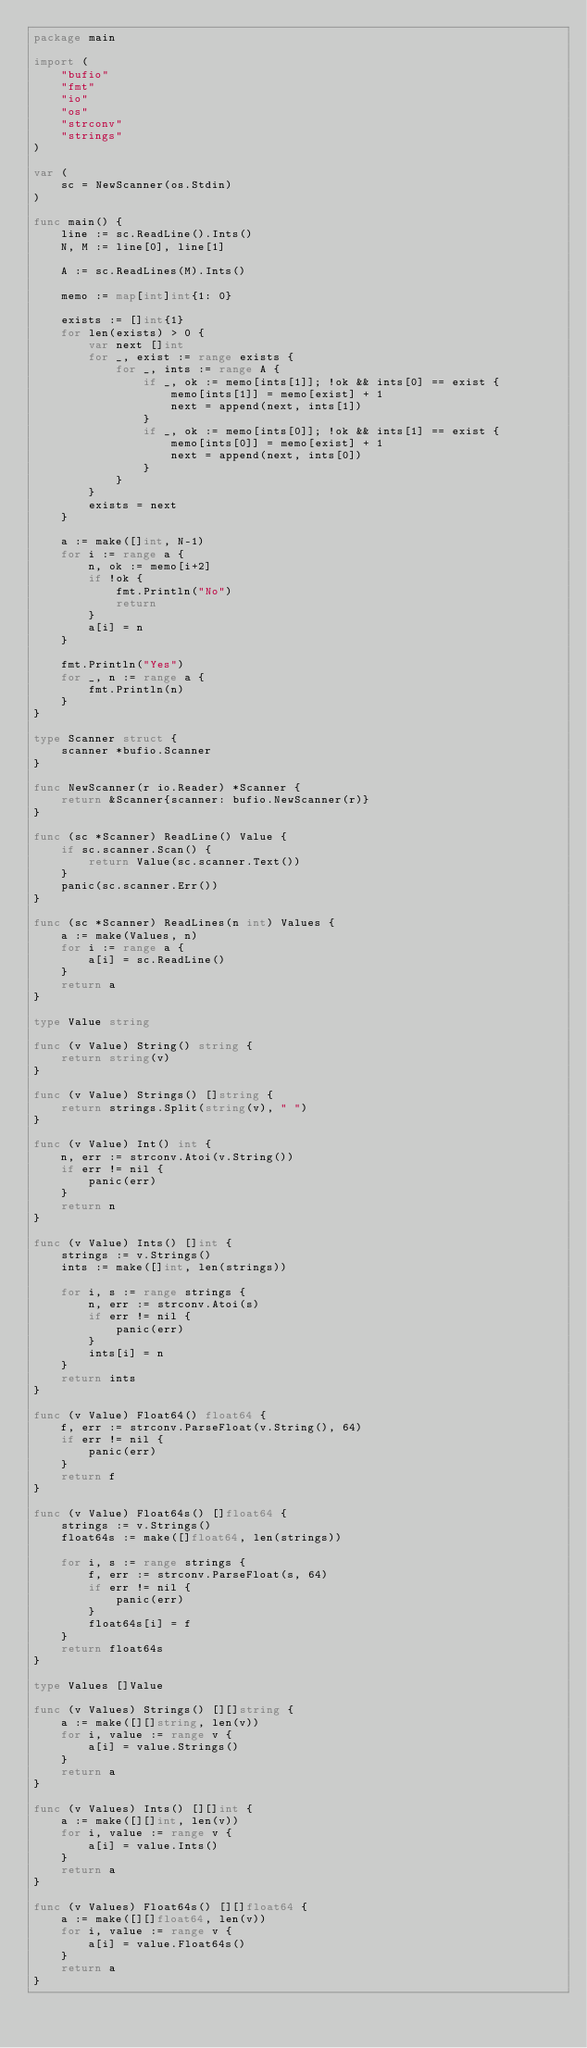Convert code to text. <code><loc_0><loc_0><loc_500><loc_500><_Go_>package main

import (
	"bufio"
	"fmt"
	"io"
	"os"
	"strconv"
	"strings"
)

var (
	sc = NewScanner(os.Stdin)
)

func main() {
	line := sc.ReadLine().Ints()
	N, M := line[0], line[1]

	A := sc.ReadLines(M).Ints()

	memo := map[int]int{1: 0}

	exists := []int{1}
	for len(exists) > 0 {
		var next []int
		for _, exist := range exists {
			for _, ints := range A {
				if _, ok := memo[ints[1]]; !ok && ints[0] == exist {
					memo[ints[1]] = memo[exist] + 1
					next = append(next, ints[1])
				}
				if _, ok := memo[ints[0]]; !ok && ints[1] == exist {
					memo[ints[0]] = memo[exist] + 1
					next = append(next, ints[0])
				}
			}
		}
		exists = next
	}

	a := make([]int, N-1)
	for i := range a {
		n, ok := memo[i+2]
		if !ok {
			fmt.Println("No")
			return
		}
		a[i] = n
	}

	fmt.Println("Yes")
	for _, n := range a {
		fmt.Println(n)
	}
}

type Scanner struct {
	scanner *bufio.Scanner
}

func NewScanner(r io.Reader) *Scanner {
	return &Scanner{scanner: bufio.NewScanner(r)}
}

func (sc *Scanner) ReadLine() Value {
	if sc.scanner.Scan() {
		return Value(sc.scanner.Text())
	}
	panic(sc.scanner.Err())
}

func (sc *Scanner) ReadLines(n int) Values {
	a := make(Values, n)
	for i := range a {
		a[i] = sc.ReadLine()
	}
	return a
}

type Value string

func (v Value) String() string {
	return string(v)
}

func (v Value) Strings() []string {
	return strings.Split(string(v), " ")
}

func (v Value) Int() int {
	n, err := strconv.Atoi(v.String())
	if err != nil {
		panic(err)
	}
	return n
}

func (v Value) Ints() []int {
	strings := v.Strings()
	ints := make([]int, len(strings))

	for i, s := range strings {
		n, err := strconv.Atoi(s)
		if err != nil {
			panic(err)
		}
		ints[i] = n
	}
	return ints
}

func (v Value) Float64() float64 {
	f, err := strconv.ParseFloat(v.String(), 64)
	if err != nil {
		panic(err)
	}
	return f
}

func (v Value) Float64s() []float64 {
	strings := v.Strings()
	float64s := make([]float64, len(strings))

	for i, s := range strings {
		f, err := strconv.ParseFloat(s, 64)
		if err != nil {
			panic(err)
		}
		float64s[i] = f
	}
	return float64s
}

type Values []Value

func (v Values) Strings() [][]string {
	a := make([][]string, len(v))
	for i, value := range v {
		a[i] = value.Strings()
	}
	return a
}

func (v Values) Ints() [][]int {
	a := make([][]int, len(v))
	for i, value := range v {
		a[i] = value.Ints()
	}
	return a
}

func (v Values) Float64s() [][]float64 {
	a := make([][]float64, len(v))
	for i, value := range v {
		a[i] = value.Float64s()
	}
	return a
}
</code> 